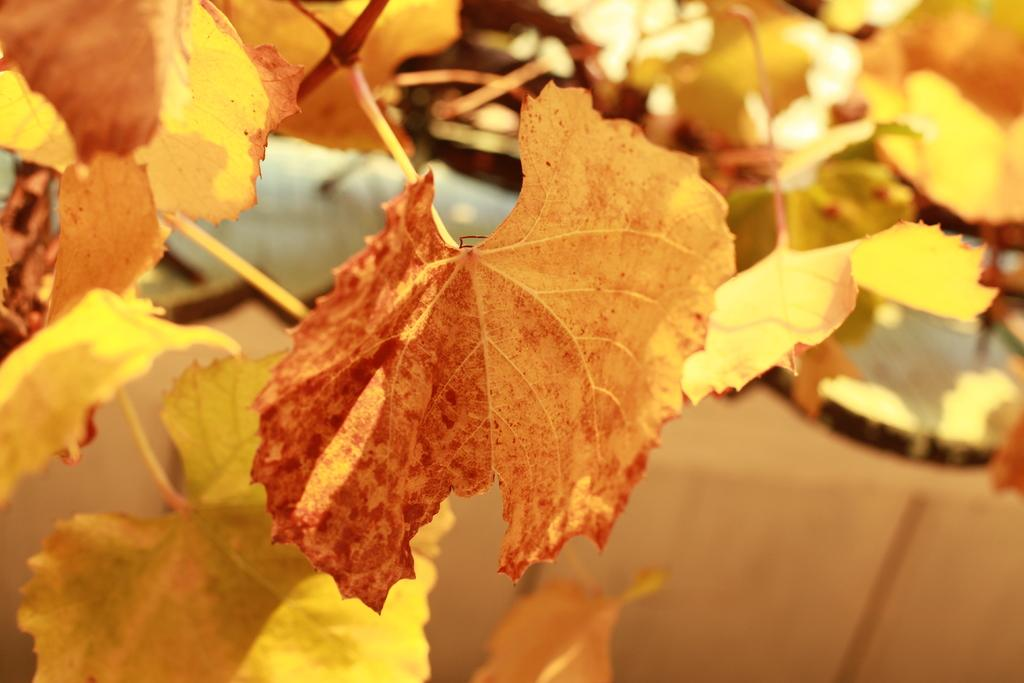What is the main subject of the image? The main subject of the image is a group of leaves. Where are the leaves located in relation to the plant? The leaves are on the stems of a plant. What type of paper can be seen in the image? There is no paper present in the image; it features a group of leaves on the stems of a plant. What season is depicted in the image? The image does not depict a specific season, as leaves can be present on plants throughout the year. 